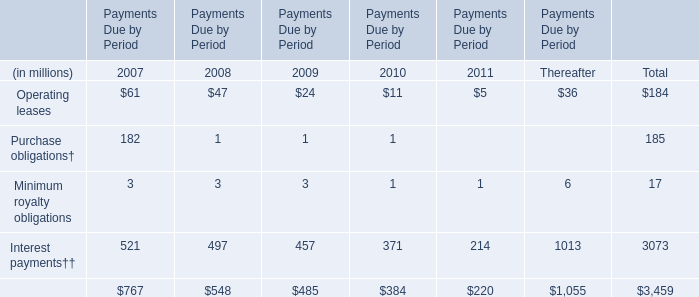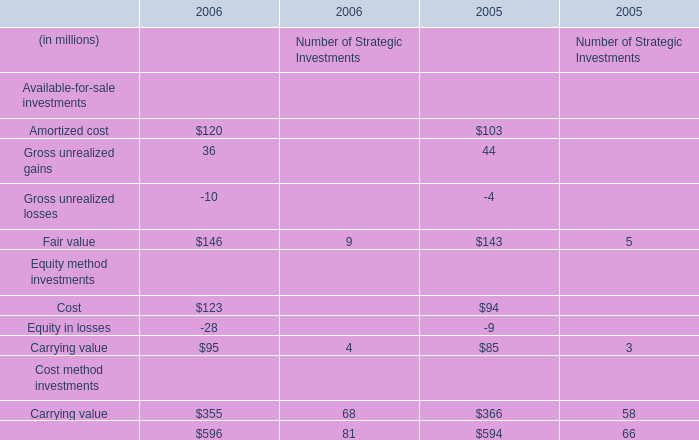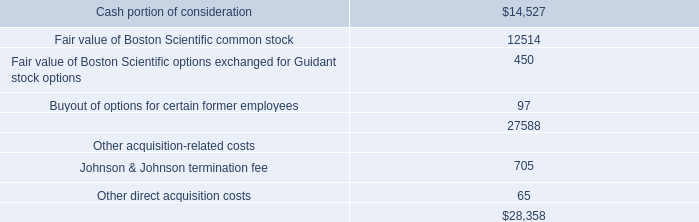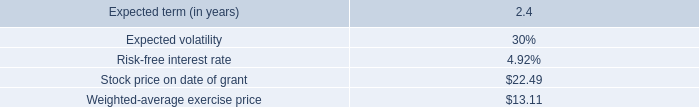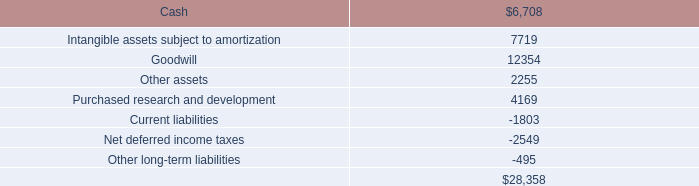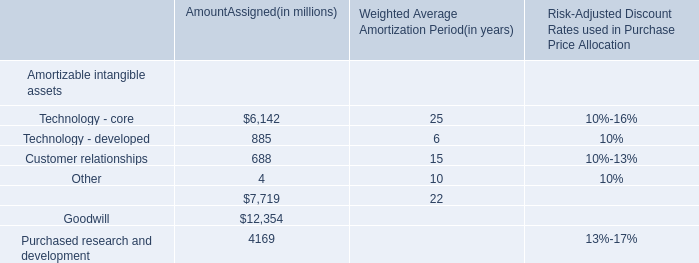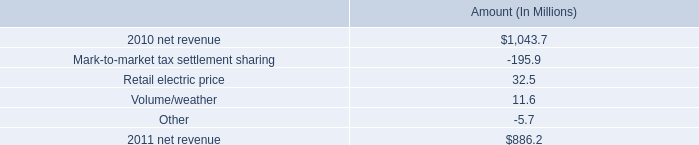what is the growth rate in net revenue from 2010 to 2011? 
Computations: ((886.2 - 1043.7) / 1043.7)
Answer: -0.15091. 